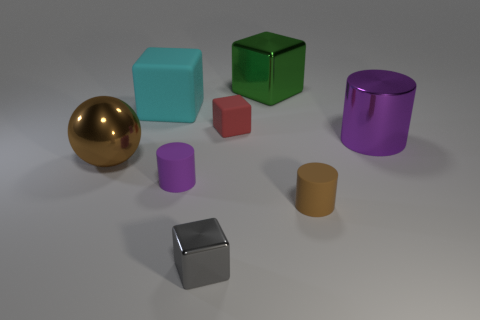What color is the cylinder that is on the right side of the brown cylinder?
Your answer should be very brief. Purple. How many big balls have the same color as the shiny cylinder?
Offer a terse response. 0. There is a green metal object; is its size the same as the purple thing in front of the big brown sphere?
Make the answer very short. No. There is a purple rubber cylinder that is to the left of the shiny cube in front of the small cube that is behind the brown sphere; what is its size?
Your answer should be compact. Small. There is a small red rubber object; what number of large metallic balls are right of it?
Provide a succinct answer. 0. The block that is behind the big block on the left side of the purple rubber object is made of what material?
Give a very brief answer. Metal. Do the gray object and the sphere have the same size?
Offer a very short reply. No. How many things are either small matte objects that are in front of the red object or large things that are right of the purple matte object?
Ensure brevity in your answer.  4. Are there more big cubes that are left of the large metal cylinder than big brown metal objects?
Provide a succinct answer. Yes. What number of other things are there of the same shape as the small metal object?
Provide a succinct answer. 3. 